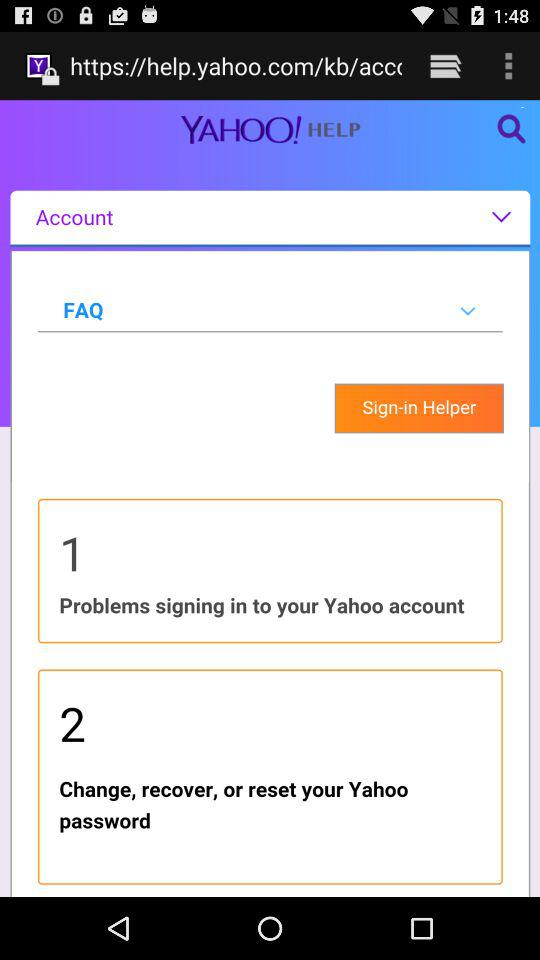What are the steps given for the Sign-in Helper?
When the provided information is insufficient, respond with <no answer>. <no answer> 